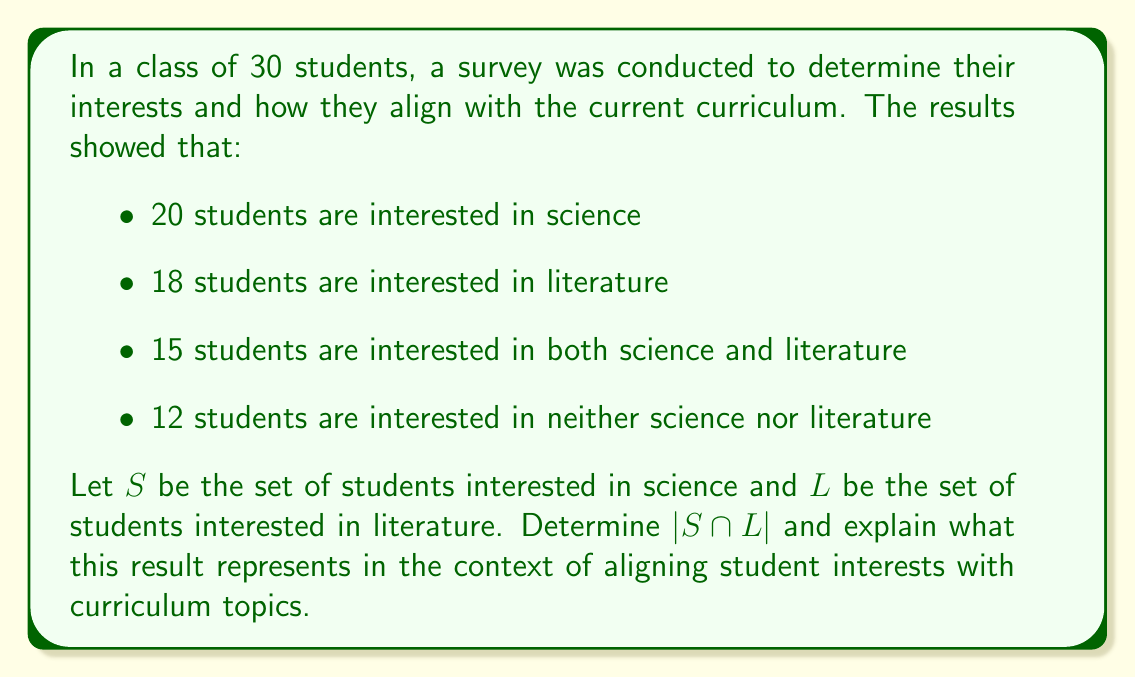Could you help me with this problem? To solve this problem, we'll use set theory concepts and the given information:

1) Let's define our universal set $U$ as all students in the class. We know $|U| = 30$.

2) We're given:
   $|S| = 20$ (students interested in science)
   $|L| = 18$ (students interested in literature)
   $|S \cap L| = 15$ (students interested in both)
   Number of students interested in neither = 12

3) We can verify our data using the principle of inclusion-exclusion:
   $|S \cup L| = |S| + |L| - |S \cap L|$
   $|S \cup L| = 20 + 18 - 15 = 23$

4) This checks out because:
   Students interested in at least one subject + Students interested in neither = Total students
   $23 + 12 = 35$

5) The intersection $S \cap L$ represents students interested in both science and literature. We're given that $|S \cap L| = 15$.

6) In the context of aligning student interests with curriculum topics, this intersection represents the number of students whose interests overlap in both science and literature. This information is valuable for designing integrated curriculum units or interdisciplinary projects that combine elements of both subjects, potentially engaging a significant portion of the class (15 out of 30 students, or 50%).
Answer: $|S \cap L| = 15$

This represents the number of students interested in both science and literature, indicating potential for integrated curriculum development. 